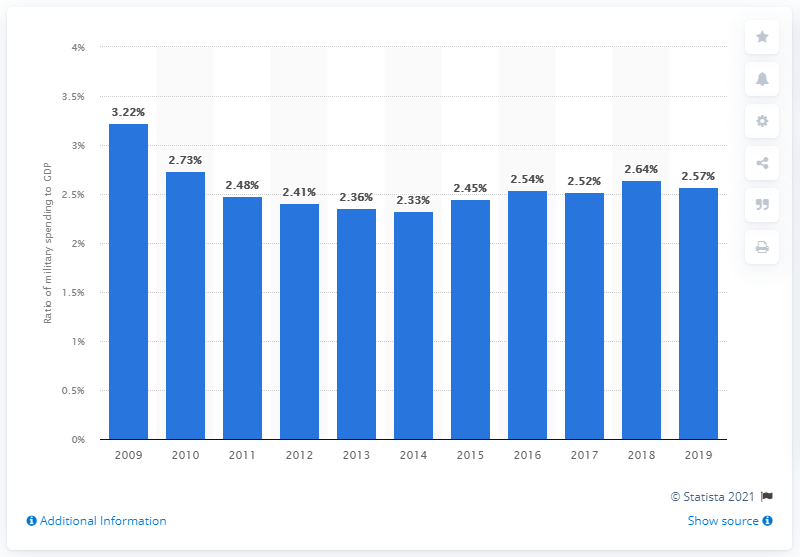Give some essential details in this illustration. In 2019, military expenditure in Greece accounted for 2.57% of the country's Gross Domestic Product (GDP), according to official government statistics. 